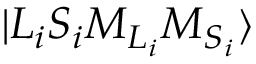Convert formula to latex. <formula><loc_0><loc_0><loc_500><loc_500>{ | { L } _ { i } { S } _ { i } { M } _ { { L } _ { i } } { M } _ { { S } _ { i } } \rangle }</formula> 